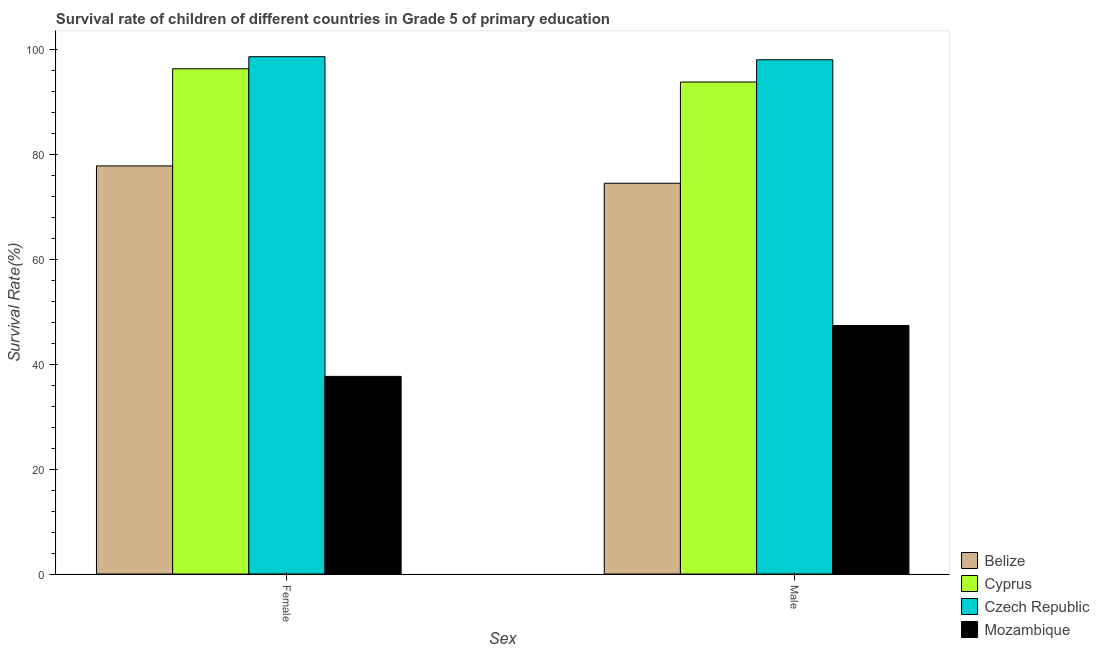How many different coloured bars are there?
Keep it short and to the point. 4. Are the number of bars per tick equal to the number of legend labels?
Make the answer very short. Yes. Are the number of bars on each tick of the X-axis equal?
Provide a succinct answer. Yes. How many bars are there on the 2nd tick from the left?
Your response must be concise. 4. What is the label of the 1st group of bars from the left?
Offer a very short reply. Female. What is the survival rate of male students in primary education in Belize?
Give a very brief answer. 74.49. Across all countries, what is the maximum survival rate of female students in primary education?
Give a very brief answer. 98.62. Across all countries, what is the minimum survival rate of male students in primary education?
Provide a succinct answer. 47.38. In which country was the survival rate of female students in primary education maximum?
Offer a terse response. Czech Republic. In which country was the survival rate of male students in primary education minimum?
Your response must be concise. Mozambique. What is the total survival rate of female students in primary education in the graph?
Give a very brief answer. 310.4. What is the difference between the survival rate of female students in primary education in Czech Republic and that in Cyprus?
Your answer should be very brief. 2.3. What is the difference between the survival rate of female students in primary education in Belize and the survival rate of male students in primary education in Cyprus?
Ensure brevity in your answer.  -15.99. What is the average survival rate of male students in primary education per country?
Offer a terse response. 78.42. What is the difference between the survival rate of female students in primary education and survival rate of male students in primary education in Belize?
Make the answer very short. 3.3. In how many countries, is the survival rate of female students in primary education greater than 4 %?
Make the answer very short. 4. What is the ratio of the survival rate of male students in primary education in Cyprus to that in Mozambique?
Offer a terse response. 1.98. Is the survival rate of female students in primary education in Czech Republic less than that in Belize?
Ensure brevity in your answer.  No. In how many countries, is the survival rate of male students in primary education greater than the average survival rate of male students in primary education taken over all countries?
Keep it short and to the point. 2. What does the 1st bar from the left in Male represents?
Your answer should be very brief. Belize. What does the 4th bar from the right in Female represents?
Provide a short and direct response. Belize. How many bars are there?
Give a very brief answer. 8. Are the values on the major ticks of Y-axis written in scientific E-notation?
Keep it short and to the point. No. Does the graph contain any zero values?
Offer a terse response. No. Does the graph contain grids?
Offer a very short reply. No. What is the title of the graph?
Your response must be concise. Survival rate of children of different countries in Grade 5 of primary education. Does "Fiji" appear as one of the legend labels in the graph?
Your answer should be compact. No. What is the label or title of the X-axis?
Provide a short and direct response. Sex. What is the label or title of the Y-axis?
Your answer should be compact. Survival Rate(%). What is the Survival Rate(%) of Belize in Female?
Your response must be concise. 77.79. What is the Survival Rate(%) of Cyprus in Female?
Your response must be concise. 96.31. What is the Survival Rate(%) in Czech Republic in Female?
Your response must be concise. 98.62. What is the Survival Rate(%) in Mozambique in Female?
Your response must be concise. 37.67. What is the Survival Rate(%) in Belize in Male?
Your answer should be compact. 74.49. What is the Survival Rate(%) in Cyprus in Male?
Ensure brevity in your answer.  93.79. What is the Survival Rate(%) of Czech Republic in Male?
Offer a terse response. 98.03. What is the Survival Rate(%) in Mozambique in Male?
Ensure brevity in your answer.  47.38. Across all Sex, what is the maximum Survival Rate(%) of Belize?
Make the answer very short. 77.79. Across all Sex, what is the maximum Survival Rate(%) of Cyprus?
Provide a succinct answer. 96.31. Across all Sex, what is the maximum Survival Rate(%) of Czech Republic?
Your answer should be compact. 98.62. Across all Sex, what is the maximum Survival Rate(%) in Mozambique?
Provide a short and direct response. 47.38. Across all Sex, what is the minimum Survival Rate(%) of Belize?
Offer a terse response. 74.49. Across all Sex, what is the minimum Survival Rate(%) of Cyprus?
Make the answer very short. 93.79. Across all Sex, what is the minimum Survival Rate(%) of Czech Republic?
Offer a very short reply. 98.03. Across all Sex, what is the minimum Survival Rate(%) in Mozambique?
Offer a terse response. 37.67. What is the total Survival Rate(%) in Belize in the graph?
Keep it short and to the point. 152.29. What is the total Survival Rate(%) in Cyprus in the graph?
Provide a short and direct response. 190.1. What is the total Survival Rate(%) of Czech Republic in the graph?
Your answer should be compact. 196.65. What is the total Survival Rate(%) of Mozambique in the graph?
Provide a succinct answer. 85.05. What is the difference between the Survival Rate(%) of Belize in Female and that in Male?
Provide a short and direct response. 3.3. What is the difference between the Survival Rate(%) in Cyprus in Female and that in Male?
Provide a succinct answer. 2.53. What is the difference between the Survival Rate(%) of Czech Republic in Female and that in Male?
Provide a succinct answer. 0.59. What is the difference between the Survival Rate(%) of Mozambique in Female and that in Male?
Keep it short and to the point. -9.7. What is the difference between the Survival Rate(%) of Belize in Female and the Survival Rate(%) of Cyprus in Male?
Ensure brevity in your answer.  -15.99. What is the difference between the Survival Rate(%) in Belize in Female and the Survival Rate(%) in Czech Republic in Male?
Offer a very short reply. -20.23. What is the difference between the Survival Rate(%) of Belize in Female and the Survival Rate(%) of Mozambique in Male?
Your answer should be compact. 30.42. What is the difference between the Survival Rate(%) in Cyprus in Female and the Survival Rate(%) in Czech Republic in Male?
Offer a terse response. -1.72. What is the difference between the Survival Rate(%) of Cyprus in Female and the Survival Rate(%) of Mozambique in Male?
Provide a succinct answer. 48.94. What is the difference between the Survival Rate(%) of Czech Republic in Female and the Survival Rate(%) of Mozambique in Male?
Your response must be concise. 51.24. What is the average Survival Rate(%) in Belize per Sex?
Your answer should be very brief. 76.14. What is the average Survival Rate(%) in Cyprus per Sex?
Keep it short and to the point. 95.05. What is the average Survival Rate(%) in Czech Republic per Sex?
Your response must be concise. 98.32. What is the average Survival Rate(%) in Mozambique per Sex?
Your response must be concise. 42.52. What is the difference between the Survival Rate(%) in Belize and Survival Rate(%) in Cyprus in Female?
Ensure brevity in your answer.  -18.52. What is the difference between the Survival Rate(%) in Belize and Survival Rate(%) in Czech Republic in Female?
Provide a short and direct response. -20.82. What is the difference between the Survival Rate(%) in Belize and Survival Rate(%) in Mozambique in Female?
Provide a succinct answer. 40.12. What is the difference between the Survival Rate(%) in Cyprus and Survival Rate(%) in Czech Republic in Female?
Your response must be concise. -2.3. What is the difference between the Survival Rate(%) in Cyprus and Survival Rate(%) in Mozambique in Female?
Make the answer very short. 58.64. What is the difference between the Survival Rate(%) of Czech Republic and Survival Rate(%) of Mozambique in Female?
Keep it short and to the point. 60.94. What is the difference between the Survival Rate(%) in Belize and Survival Rate(%) in Cyprus in Male?
Offer a terse response. -19.29. What is the difference between the Survival Rate(%) of Belize and Survival Rate(%) of Czech Republic in Male?
Provide a succinct answer. -23.54. What is the difference between the Survival Rate(%) of Belize and Survival Rate(%) of Mozambique in Male?
Keep it short and to the point. 27.12. What is the difference between the Survival Rate(%) in Cyprus and Survival Rate(%) in Czech Republic in Male?
Make the answer very short. -4.24. What is the difference between the Survival Rate(%) of Cyprus and Survival Rate(%) of Mozambique in Male?
Provide a short and direct response. 46.41. What is the difference between the Survival Rate(%) of Czech Republic and Survival Rate(%) of Mozambique in Male?
Give a very brief answer. 50.65. What is the ratio of the Survival Rate(%) of Belize in Female to that in Male?
Provide a succinct answer. 1.04. What is the ratio of the Survival Rate(%) of Cyprus in Female to that in Male?
Offer a terse response. 1.03. What is the ratio of the Survival Rate(%) of Mozambique in Female to that in Male?
Offer a very short reply. 0.8. What is the difference between the highest and the second highest Survival Rate(%) in Belize?
Give a very brief answer. 3.3. What is the difference between the highest and the second highest Survival Rate(%) in Cyprus?
Provide a succinct answer. 2.53. What is the difference between the highest and the second highest Survival Rate(%) of Czech Republic?
Provide a succinct answer. 0.59. What is the difference between the highest and the second highest Survival Rate(%) in Mozambique?
Offer a very short reply. 9.7. What is the difference between the highest and the lowest Survival Rate(%) in Belize?
Your response must be concise. 3.3. What is the difference between the highest and the lowest Survival Rate(%) of Cyprus?
Provide a succinct answer. 2.53. What is the difference between the highest and the lowest Survival Rate(%) in Czech Republic?
Offer a terse response. 0.59. What is the difference between the highest and the lowest Survival Rate(%) in Mozambique?
Offer a very short reply. 9.7. 